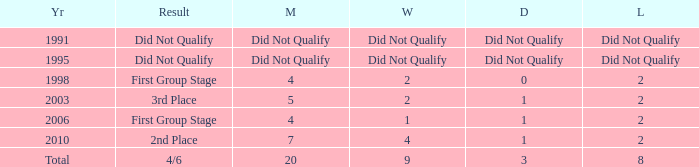What was the result for the team with 3 draws? 4/6. 